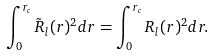Convert formula to latex. <formula><loc_0><loc_0><loc_500><loc_500>\int _ { 0 } ^ { r _ { c } } \tilde { R } _ { l } ( r ) ^ { 2 } d r = \int _ { 0 } ^ { r _ { c } } { R } _ { l } ( r ) ^ { 2 } d r .</formula> 